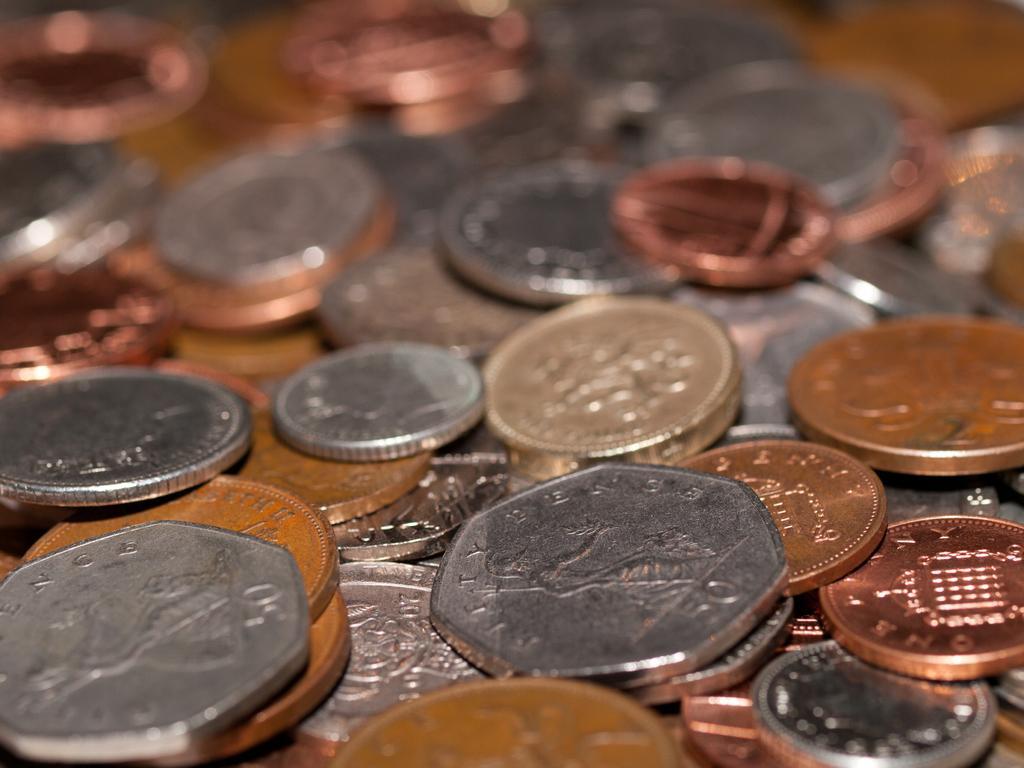In one or two sentences, can you explain what this image depicts? This is a zoomed in picture. In the foreground we can see there are many number of currency coins placed on an object. The background of the image is blurry. 